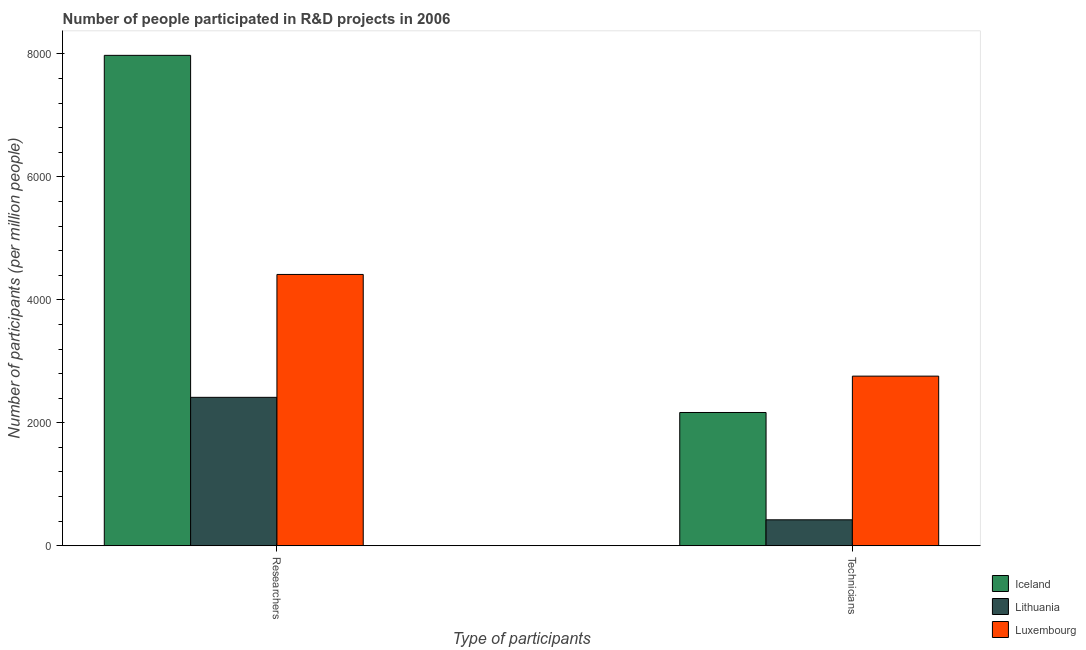How many groups of bars are there?
Give a very brief answer. 2. Are the number of bars on each tick of the X-axis equal?
Make the answer very short. Yes. How many bars are there on the 1st tick from the left?
Give a very brief answer. 3. What is the label of the 2nd group of bars from the left?
Ensure brevity in your answer.  Technicians. What is the number of researchers in Luxembourg?
Give a very brief answer. 4412.45. Across all countries, what is the maximum number of technicians?
Provide a short and direct response. 2758.91. Across all countries, what is the minimum number of technicians?
Ensure brevity in your answer.  422.32. In which country was the number of technicians maximum?
Offer a very short reply. Luxembourg. In which country was the number of researchers minimum?
Provide a succinct answer. Lithuania. What is the total number of researchers in the graph?
Ensure brevity in your answer.  1.48e+04. What is the difference between the number of technicians in Lithuania and that in Luxembourg?
Offer a very short reply. -2336.59. What is the difference between the number of researchers in Lithuania and the number of technicians in Luxembourg?
Give a very brief answer. -344.77. What is the average number of researchers per country?
Give a very brief answer. 4934.07. What is the difference between the number of researchers and number of technicians in Luxembourg?
Keep it short and to the point. 1653.54. What is the ratio of the number of technicians in Lithuania to that in Iceland?
Provide a succinct answer. 0.19. Is the number of technicians in Luxembourg less than that in Lithuania?
Keep it short and to the point. No. In how many countries, is the number of researchers greater than the average number of researchers taken over all countries?
Give a very brief answer. 1. What does the 2nd bar from the left in Technicians represents?
Ensure brevity in your answer.  Lithuania. What does the 3rd bar from the right in Technicians represents?
Provide a succinct answer. Iceland. How many countries are there in the graph?
Offer a terse response. 3. Are the values on the major ticks of Y-axis written in scientific E-notation?
Make the answer very short. No. Does the graph contain any zero values?
Make the answer very short. No. Where does the legend appear in the graph?
Give a very brief answer. Bottom right. How many legend labels are there?
Ensure brevity in your answer.  3. What is the title of the graph?
Your response must be concise. Number of people participated in R&D projects in 2006. Does "Haiti" appear as one of the legend labels in the graph?
Provide a succinct answer. No. What is the label or title of the X-axis?
Your response must be concise. Type of participants. What is the label or title of the Y-axis?
Give a very brief answer. Number of participants (per million people). What is the Number of participants (per million people) of Iceland in Researchers?
Offer a very short reply. 7975.62. What is the Number of participants (per million people) of Lithuania in Researchers?
Ensure brevity in your answer.  2414.14. What is the Number of participants (per million people) of Luxembourg in Researchers?
Offer a very short reply. 4412.45. What is the Number of participants (per million people) in Iceland in Technicians?
Your response must be concise. 2167.56. What is the Number of participants (per million people) of Lithuania in Technicians?
Ensure brevity in your answer.  422.32. What is the Number of participants (per million people) of Luxembourg in Technicians?
Ensure brevity in your answer.  2758.91. Across all Type of participants, what is the maximum Number of participants (per million people) in Iceland?
Keep it short and to the point. 7975.62. Across all Type of participants, what is the maximum Number of participants (per million people) in Lithuania?
Offer a very short reply. 2414.14. Across all Type of participants, what is the maximum Number of participants (per million people) of Luxembourg?
Your answer should be compact. 4412.45. Across all Type of participants, what is the minimum Number of participants (per million people) in Iceland?
Keep it short and to the point. 2167.56. Across all Type of participants, what is the minimum Number of participants (per million people) in Lithuania?
Give a very brief answer. 422.32. Across all Type of participants, what is the minimum Number of participants (per million people) in Luxembourg?
Keep it short and to the point. 2758.91. What is the total Number of participants (per million people) of Iceland in the graph?
Make the answer very short. 1.01e+04. What is the total Number of participants (per million people) in Lithuania in the graph?
Provide a succinct answer. 2836.46. What is the total Number of participants (per million people) in Luxembourg in the graph?
Make the answer very short. 7171.36. What is the difference between the Number of participants (per million people) of Iceland in Researchers and that in Technicians?
Offer a terse response. 5808.06. What is the difference between the Number of participants (per million people) of Lithuania in Researchers and that in Technicians?
Offer a very short reply. 1991.81. What is the difference between the Number of participants (per million people) in Luxembourg in Researchers and that in Technicians?
Offer a terse response. 1653.54. What is the difference between the Number of participants (per million people) of Iceland in Researchers and the Number of participants (per million people) of Lithuania in Technicians?
Your answer should be compact. 7553.3. What is the difference between the Number of participants (per million people) in Iceland in Researchers and the Number of participants (per million people) in Luxembourg in Technicians?
Give a very brief answer. 5216.71. What is the difference between the Number of participants (per million people) in Lithuania in Researchers and the Number of participants (per million people) in Luxembourg in Technicians?
Give a very brief answer. -344.77. What is the average Number of participants (per million people) of Iceland per Type of participants?
Provide a short and direct response. 5071.59. What is the average Number of participants (per million people) of Lithuania per Type of participants?
Make the answer very short. 1418.23. What is the average Number of participants (per million people) of Luxembourg per Type of participants?
Give a very brief answer. 3585.68. What is the difference between the Number of participants (per million people) in Iceland and Number of participants (per million people) in Lithuania in Researchers?
Your answer should be very brief. 5561.48. What is the difference between the Number of participants (per million people) of Iceland and Number of participants (per million people) of Luxembourg in Researchers?
Offer a very short reply. 3563.17. What is the difference between the Number of participants (per million people) in Lithuania and Number of participants (per million people) in Luxembourg in Researchers?
Provide a short and direct response. -1998.32. What is the difference between the Number of participants (per million people) of Iceland and Number of participants (per million people) of Lithuania in Technicians?
Provide a short and direct response. 1745.24. What is the difference between the Number of participants (per million people) of Iceland and Number of participants (per million people) of Luxembourg in Technicians?
Give a very brief answer. -591.35. What is the difference between the Number of participants (per million people) in Lithuania and Number of participants (per million people) in Luxembourg in Technicians?
Keep it short and to the point. -2336.59. What is the ratio of the Number of participants (per million people) in Iceland in Researchers to that in Technicians?
Provide a succinct answer. 3.68. What is the ratio of the Number of participants (per million people) of Lithuania in Researchers to that in Technicians?
Your response must be concise. 5.72. What is the ratio of the Number of participants (per million people) in Luxembourg in Researchers to that in Technicians?
Make the answer very short. 1.6. What is the difference between the highest and the second highest Number of participants (per million people) in Iceland?
Offer a very short reply. 5808.06. What is the difference between the highest and the second highest Number of participants (per million people) in Lithuania?
Provide a succinct answer. 1991.81. What is the difference between the highest and the second highest Number of participants (per million people) of Luxembourg?
Make the answer very short. 1653.54. What is the difference between the highest and the lowest Number of participants (per million people) in Iceland?
Give a very brief answer. 5808.06. What is the difference between the highest and the lowest Number of participants (per million people) of Lithuania?
Your response must be concise. 1991.81. What is the difference between the highest and the lowest Number of participants (per million people) of Luxembourg?
Offer a terse response. 1653.54. 